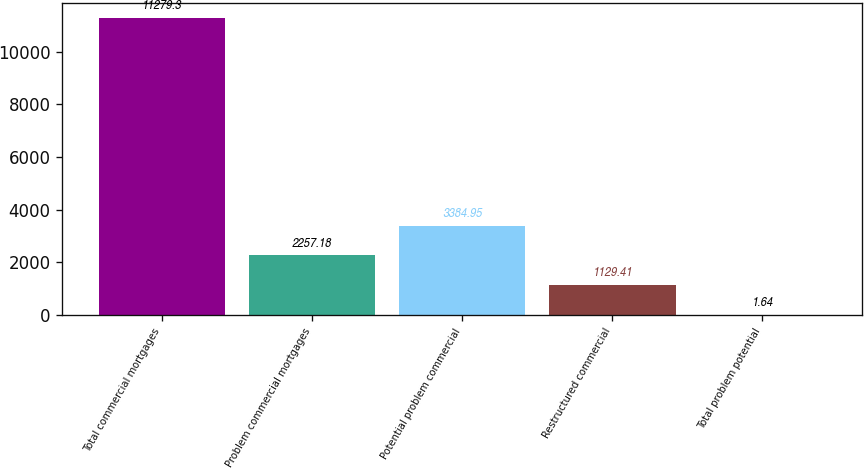<chart> <loc_0><loc_0><loc_500><loc_500><bar_chart><fcel>Total commercial mortgages<fcel>Problem commercial mortgages<fcel>Potential problem commercial<fcel>Restructured commercial<fcel>Total problem potential<nl><fcel>11279.3<fcel>2257.18<fcel>3384.95<fcel>1129.41<fcel>1.64<nl></chart> 